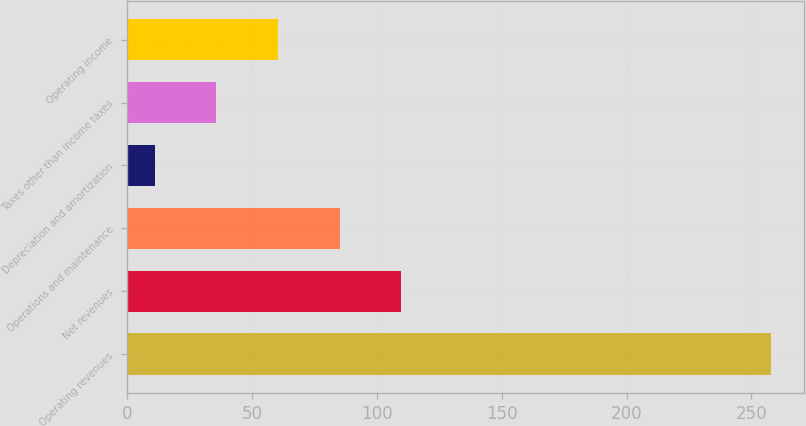<chart> <loc_0><loc_0><loc_500><loc_500><bar_chart><fcel>Operating revenues<fcel>Net revenues<fcel>Operations and maintenance<fcel>Depreciation and amortization<fcel>Taxes other than income taxes<fcel>Operating income<nl><fcel>258<fcel>109.8<fcel>85.1<fcel>11<fcel>35.7<fcel>60.4<nl></chart> 